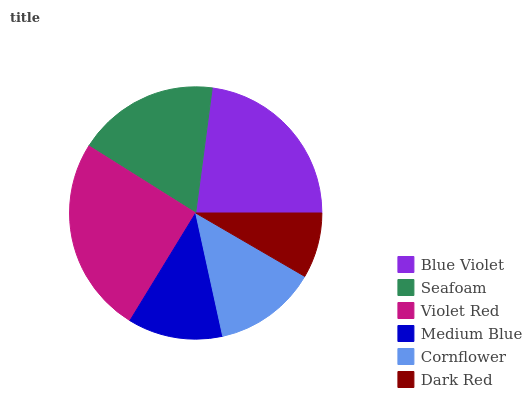Is Dark Red the minimum?
Answer yes or no. Yes. Is Violet Red the maximum?
Answer yes or no. Yes. Is Seafoam the minimum?
Answer yes or no. No. Is Seafoam the maximum?
Answer yes or no. No. Is Blue Violet greater than Seafoam?
Answer yes or no. Yes. Is Seafoam less than Blue Violet?
Answer yes or no. Yes. Is Seafoam greater than Blue Violet?
Answer yes or no. No. Is Blue Violet less than Seafoam?
Answer yes or no. No. Is Seafoam the high median?
Answer yes or no. Yes. Is Cornflower the low median?
Answer yes or no. Yes. Is Dark Red the high median?
Answer yes or no. No. Is Blue Violet the low median?
Answer yes or no. No. 